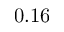Convert formula to latex. <formula><loc_0><loc_0><loc_500><loc_500>0 . 1 6</formula> 